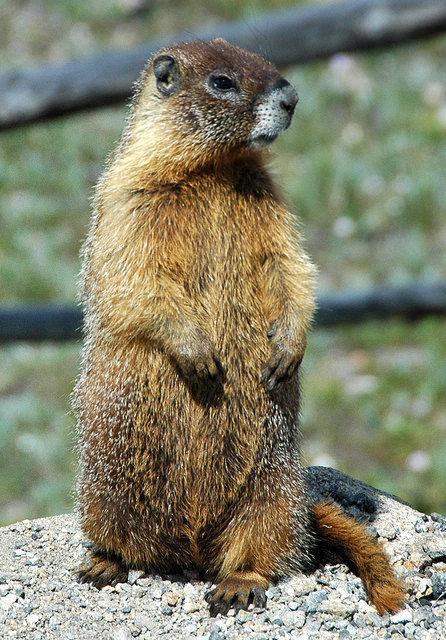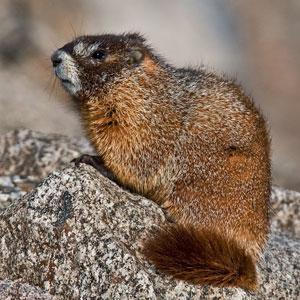The first image is the image on the left, the second image is the image on the right. Analyze the images presented: Is the assertion "An image shows a marmot standing upright, with its front paws hanging downward." valid? Answer yes or no. Yes. The first image is the image on the left, the second image is the image on the right. For the images displayed, is the sentence "There is at least one ground hog with its front paws resting on a rock." factually correct? Answer yes or no. Yes. 